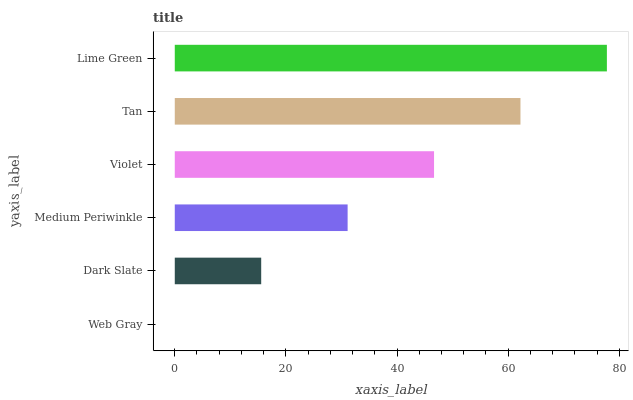Is Web Gray the minimum?
Answer yes or no. Yes. Is Lime Green the maximum?
Answer yes or no. Yes. Is Dark Slate the minimum?
Answer yes or no. No. Is Dark Slate the maximum?
Answer yes or no. No. Is Dark Slate greater than Web Gray?
Answer yes or no. Yes. Is Web Gray less than Dark Slate?
Answer yes or no. Yes. Is Web Gray greater than Dark Slate?
Answer yes or no. No. Is Dark Slate less than Web Gray?
Answer yes or no. No. Is Violet the high median?
Answer yes or no. Yes. Is Medium Periwinkle the low median?
Answer yes or no. Yes. Is Medium Periwinkle the high median?
Answer yes or no. No. Is Violet the low median?
Answer yes or no. No. 